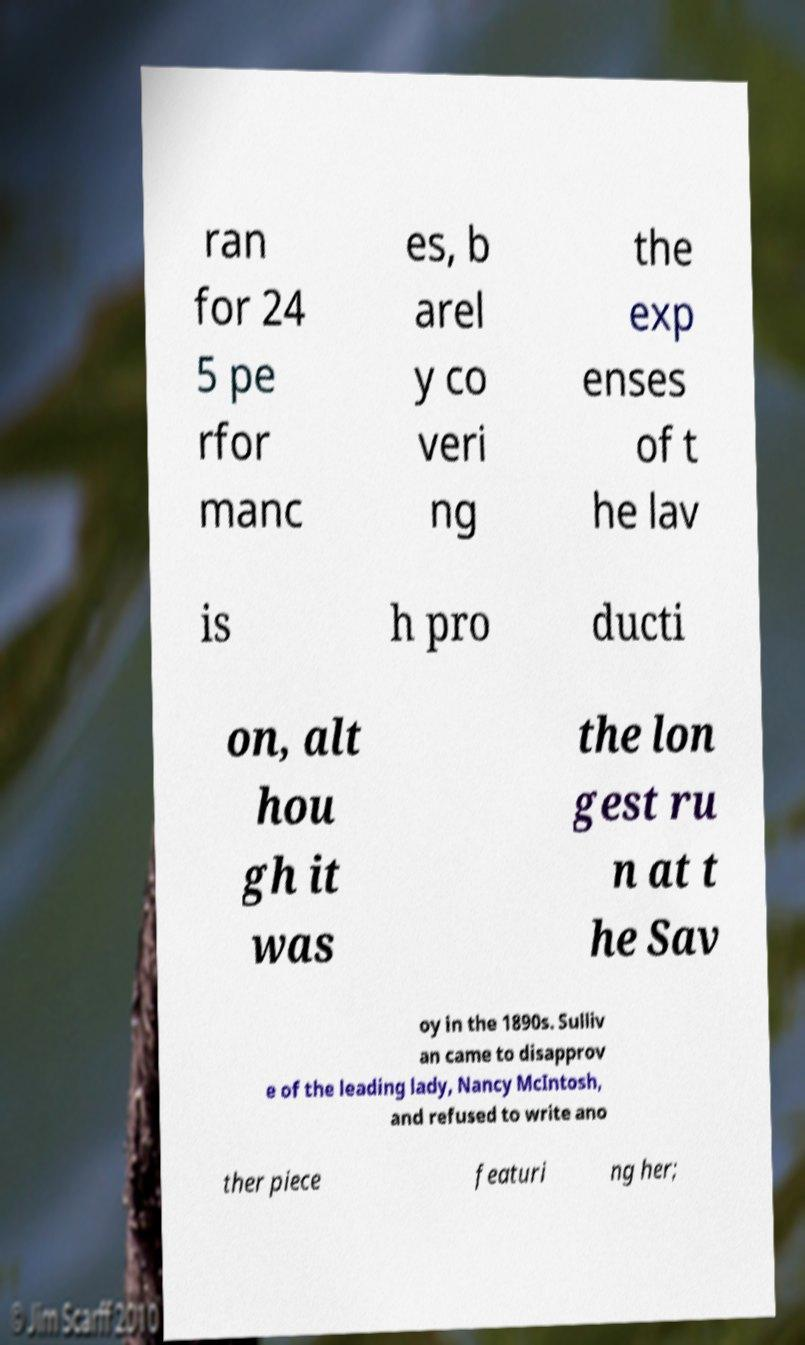I need the written content from this picture converted into text. Can you do that? ran for 24 5 pe rfor manc es, b arel y co veri ng the exp enses of t he lav is h pro ducti on, alt hou gh it was the lon gest ru n at t he Sav oy in the 1890s. Sulliv an came to disapprov e of the leading lady, Nancy McIntosh, and refused to write ano ther piece featuri ng her; 